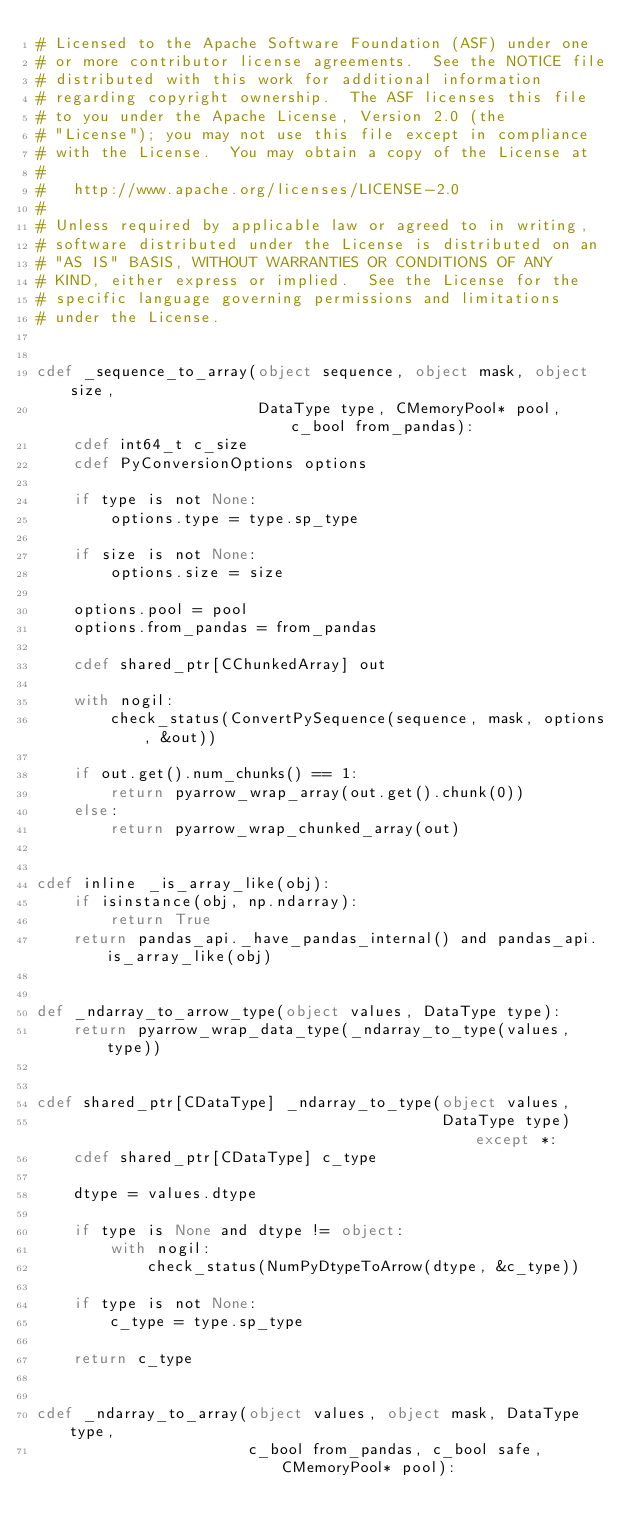<code> <loc_0><loc_0><loc_500><loc_500><_Cython_># Licensed to the Apache Software Foundation (ASF) under one
# or more contributor license agreements.  See the NOTICE file
# distributed with this work for additional information
# regarding copyright ownership.  The ASF licenses this file
# to you under the Apache License, Version 2.0 (the
# "License"); you may not use this file except in compliance
# with the License.  You may obtain a copy of the License at
#
#   http://www.apache.org/licenses/LICENSE-2.0
#
# Unless required by applicable law or agreed to in writing,
# software distributed under the License is distributed on an
# "AS IS" BASIS, WITHOUT WARRANTIES OR CONDITIONS OF ANY
# KIND, either express or implied.  See the License for the
# specific language governing permissions and limitations
# under the License.


cdef _sequence_to_array(object sequence, object mask, object size,
                        DataType type, CMemoryPool* pool, c_bool from_pandas):
    cdef int64_t c_size
    cdef PyConversionOptions options

    if type is not None:
        options.type = type.sp_type

    if size is not None:
        options.size = size

    options.pool = pool
    options.from_pandas = from_pandas

    cdef shared_ptr[CChunkedArray] out

    with nogil:
        check_status(ConvertPySequence(sequence, mask, options, &out))

    if out.get().num_chunks() == 1:
        return pyarrow_wrap_array(out.get().chunk(0))
    else:
        return pyarrow_wrap_chunked_array(out)


cdef inline _is_array_like(obj):
    if isinstance(obj, np.ndarray):
        return True
    return pandas_api._have_pandas_internal() and pandas_api.is_array_like(obj)


def _ndarray_to_arrow_type(object values, DataType type):
    return pyarrow_wrap_data_type(_ndarray_to_type(values, type))


cdef shared_ptr[CDataType] _ndarray_to_type(object values,
                                            DataType type) except *:
    cdef shared_ptr[CDataType] c_type

    dtype = values.dtype

    if type is None and dtype != object:
        with nogil:
            check_status(NumPyDtypeToArrow(dtype, &c_type))

    if type is not None:
        c_type = type.sp_type

    return c_type


cdef _ndarray_to_array(object values, object mask, DataType type,
                       c_bool from_pandas, c_bool safe, CMemoryPool* pool):</code> 